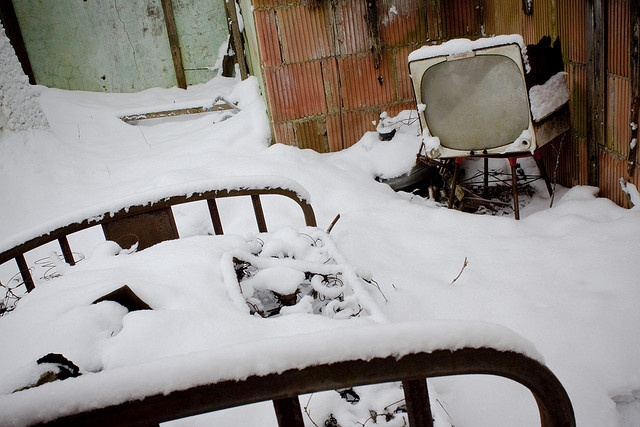Describe the objects in this image and their specific colors. I can see bed in black, lightgray, and darkgray tones and tv in black, gray, and darkgray tones in this image. 